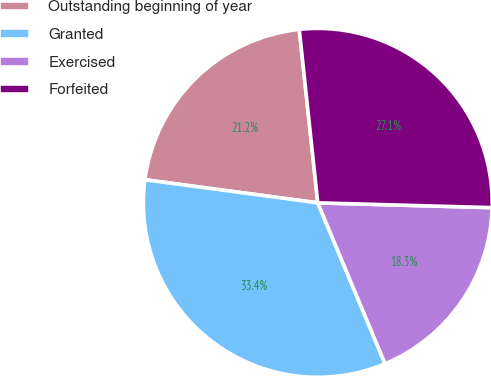Convert chart. <chart><loc_0><loc_0><loc_500><loc_500><pie_chart><fcel>Outstanding beginning of year<fcel>Granted<fcel>Exercised<fcel>Forfeited<nl><fcel>21.19%<fcel>33.42%<fcel>18.26%<fcel>27.13%<nl></chart> 